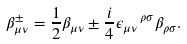Convert formula to latex. <formula><loc_0><loc_0><loc_500><loc_500>\beta _ { \mu \nu } ^ { \pm } = \frac { 1 } { 2 } \beta _ { \mu \nu } \pm \frac { i } { 4 } \epsilon _ { \mu \nu } \, ^ { \rho \sigma } \beta _ { \rho \sigma } .</formula> 